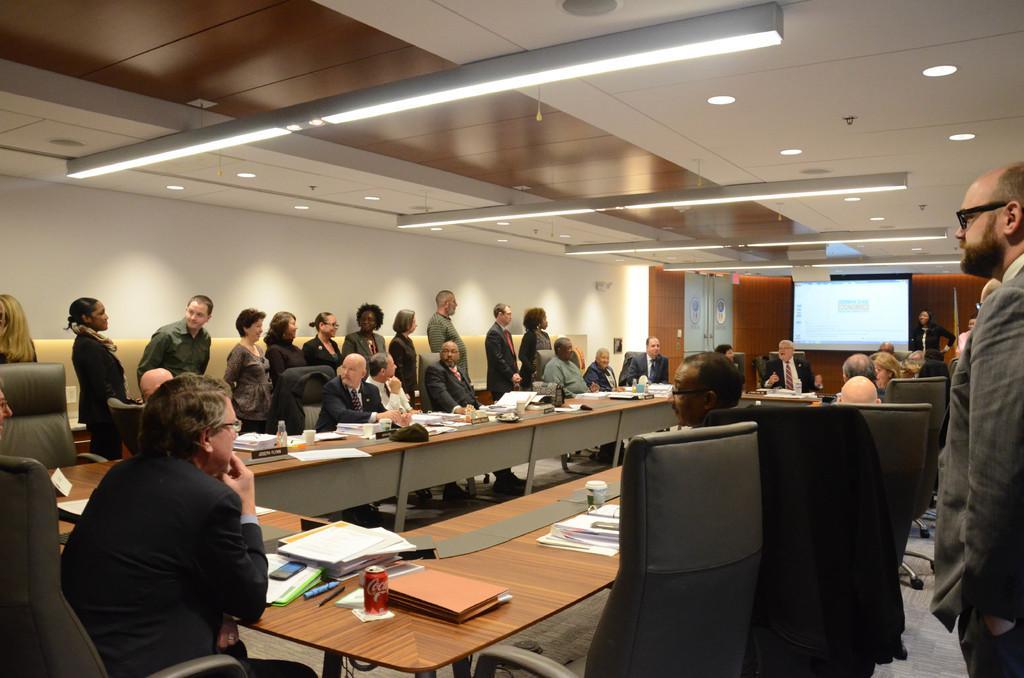Describe this image in one or two sentences. There are lot of people on room few of them are standing and few of them are sitting on chairs in front of table with some papers and pens and lot of stuff in it viewing at the screen on the other side. 